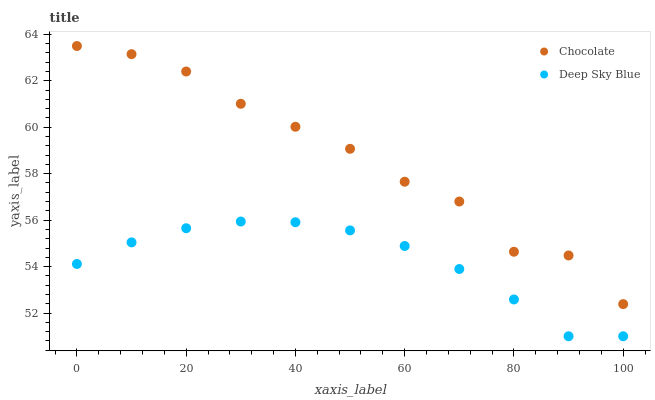Does Deep Sky Blue have the minimum area under the curve?
Answer yes or no. Yes. Does Chocolate have the maximum area under the curve?
Answer yes or no. Yes. Does Chocolate have the minimum area under the curve?
Answer yes or no. No. Is Deep Sky Blue the smoothest?
Answer yes or no. Yes. Is Chocolate the roughest?
Answer yes or no. Yes. Is Chocolate the smoothest?
Answer yes or no. No. Does Deep Sky Blue have the lowest value?
Answer yes or no. Yes. Does Chocolate have the lowest value?
Answer yes or no. No. Does Chocolate have the highest value?
Answer yes or no. Yes. Is Deep Sky Blue less than Chocolate?
Answer yes or no. Yes. Is Chocolate greater than Deep Sky Blue?
Answer yes or no. Yes. Does Deep Sky Blue intersect Chocolate?
Answer yes or no. No. 